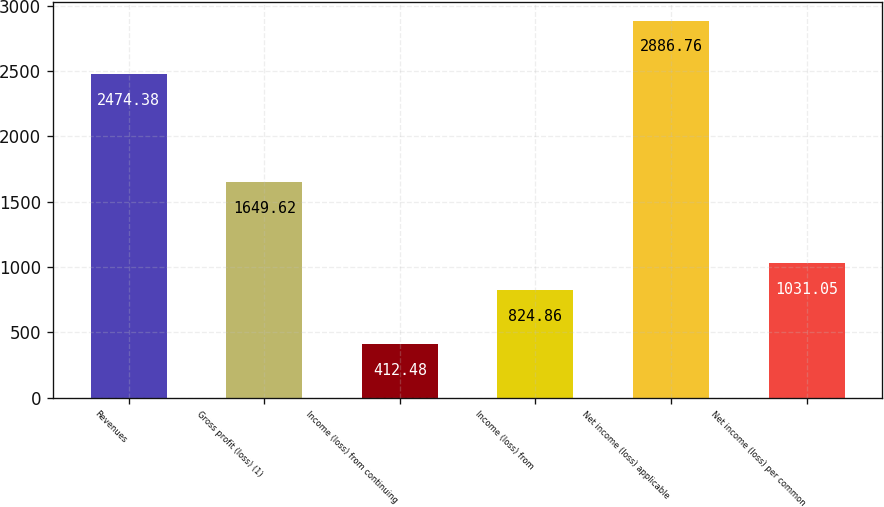Convert chart. <chart><loc_0><loc_0><loc_500><loc_500><bar_chart><fcel>Revenues<fcel>Gross profit (loss) (1)<fcel>Income (loss) from continuing<fcel>Income (loss) from<fcel>Net income (loss) applicable<fcel>Net income (loss) per common<nl><fcel>2474.38<fcel>1649.62<fcel>412.48<fcel>824.86<fcel>2886.76<fcel>1031.05<nl></chart> 